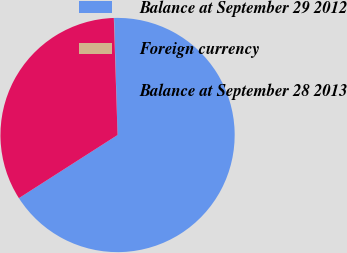Convert chart to OTSL. <chart><loc_0><loc_0><loc_500><loc_500><pie_chart><fcel>Balance at September 29 2012<fcel>Foreign currency<fcel>Balance at September 28 2013<nl><fcel>66.42%<fcel>0.03%<fcel>33.55%<nl></chart> 